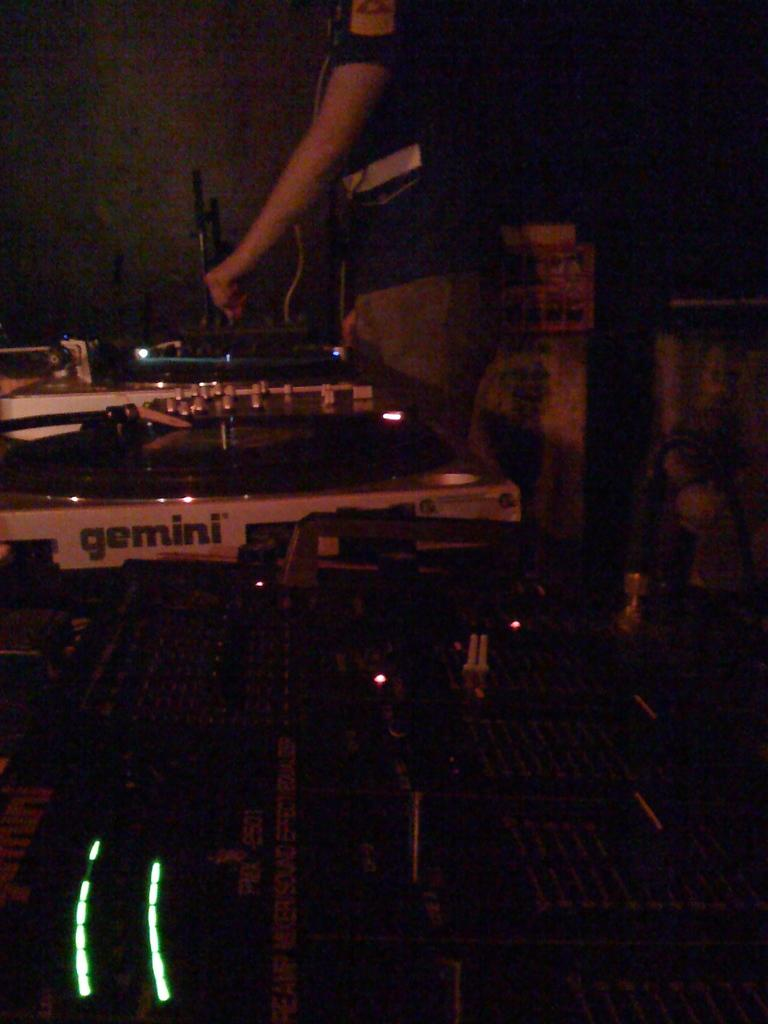What type of objects can be seen in the image? There are machines, a microphone, and a wire in the image. Can you describe the person in the image? A person is standing at the top of the image. What can be seen in the background of the image? There are pillars, a board, and stands in the background of the image. What type of growth can be seen on the writer in the image? There is no writer present in the image, and therefore no growth can be observed. 